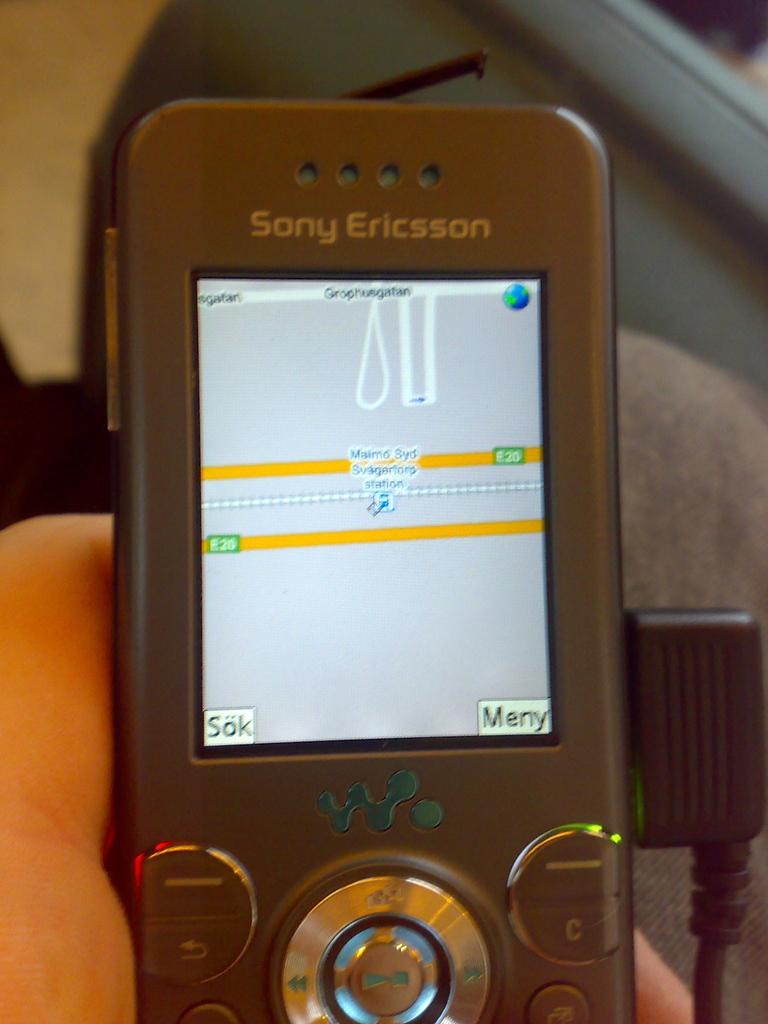What is the make of this phone?
Keep it short and to the point. Sony ericsson. What is the option in the botton right of the screen?
Your answer should be very brief. Meny. 